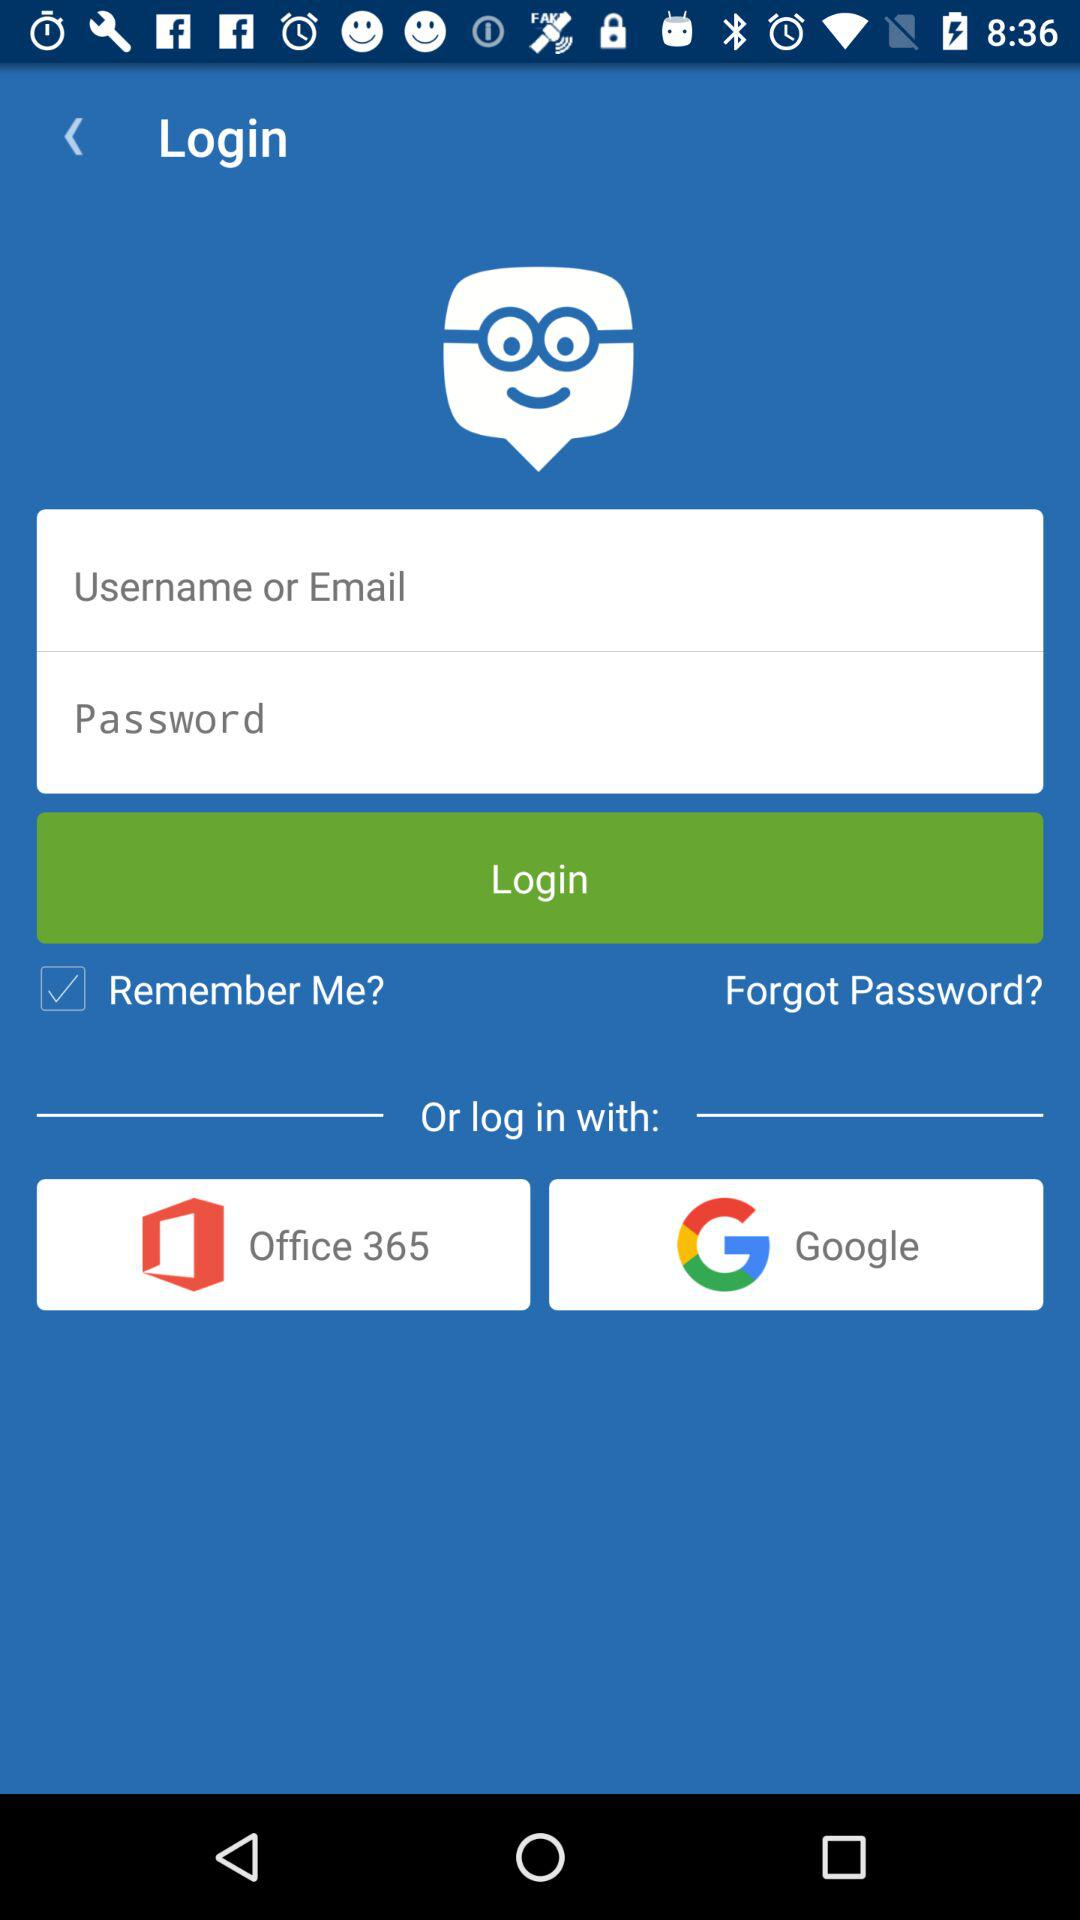Which application should I choose to log in? You should choose "Office 365" and "Google" applications to log in. 